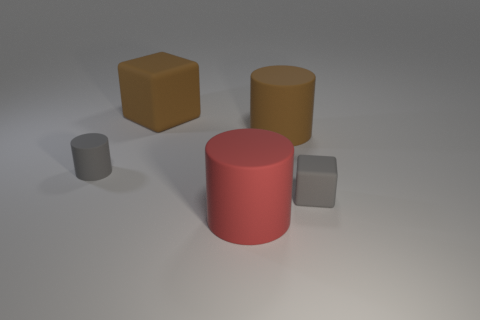Add 4 rubber things. How many objects exist? 9 Subtract all cubes. How many objects are left? 3 Subtract 0 yellow blocks. How many objects are left? 5 Subtract all large red rubber cylinders. Subtract all gray blocks. How many objects are left? 3 Add 2 gray rubber blocks. How many gray rubber blocks are left? 3 Add 3 small brown rubber balls. How many small brown rubber balls exist? 3 